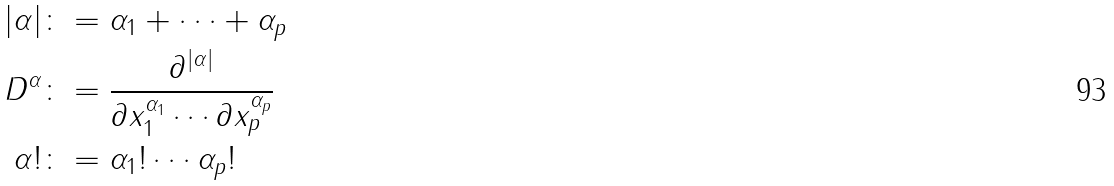Convert formula to latex. <formula><loc_0><loc_0><loc_500><loc_500>| \alpha | & \colon = \alpha _ { 1 } + \cdots + \alpha _ { p } \\ D ^ { \alpha } & \colon = \frac { \partial ^ { | \alpha | } } { \partial x _ { 1 } ^ { \alpha _ { 1 } } \cdots \partial x _ { p } ^ { \alpha _ { p } } } \\ \alpha ! & \colon = \alpha _ { 1 } ! \cdots \alpha _ { p } !</formula> 